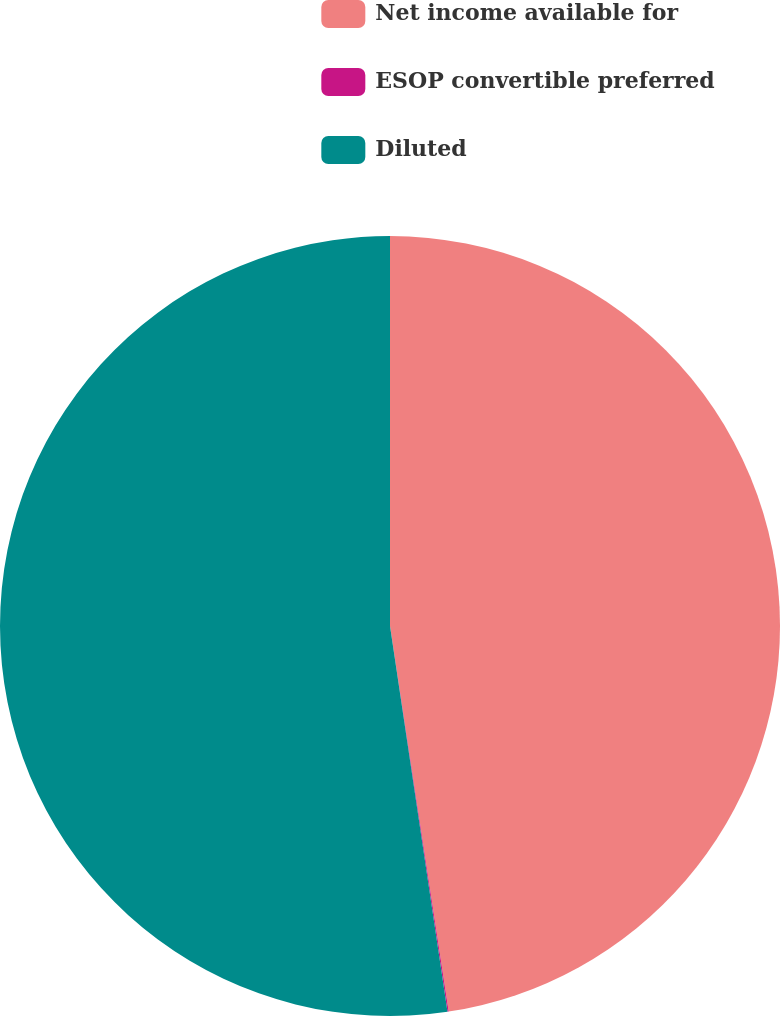Convert chart to OTSL. <chart><loc_0><loc_0><loc_500><loc_500><pie_chart><fcel>Net income available for<fcel>ESOP convertible preferred<fcel>Diluted<nl><fcel>47.6%<fcel>0.05%<fcel>52.36%<nl></chart> 